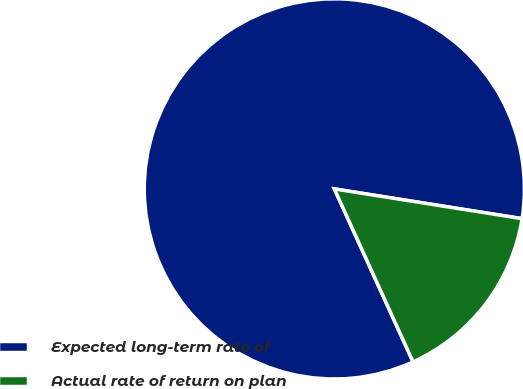Convert chart to OTSL. <chart><loc_0><loc_0><loc_500><loc_500><pie_chart><fcel>Expected long-term rate of<fcel>Actual rate of return on plan<nl><fcel>84.3%<fcel>15.7%<nl></chart> 